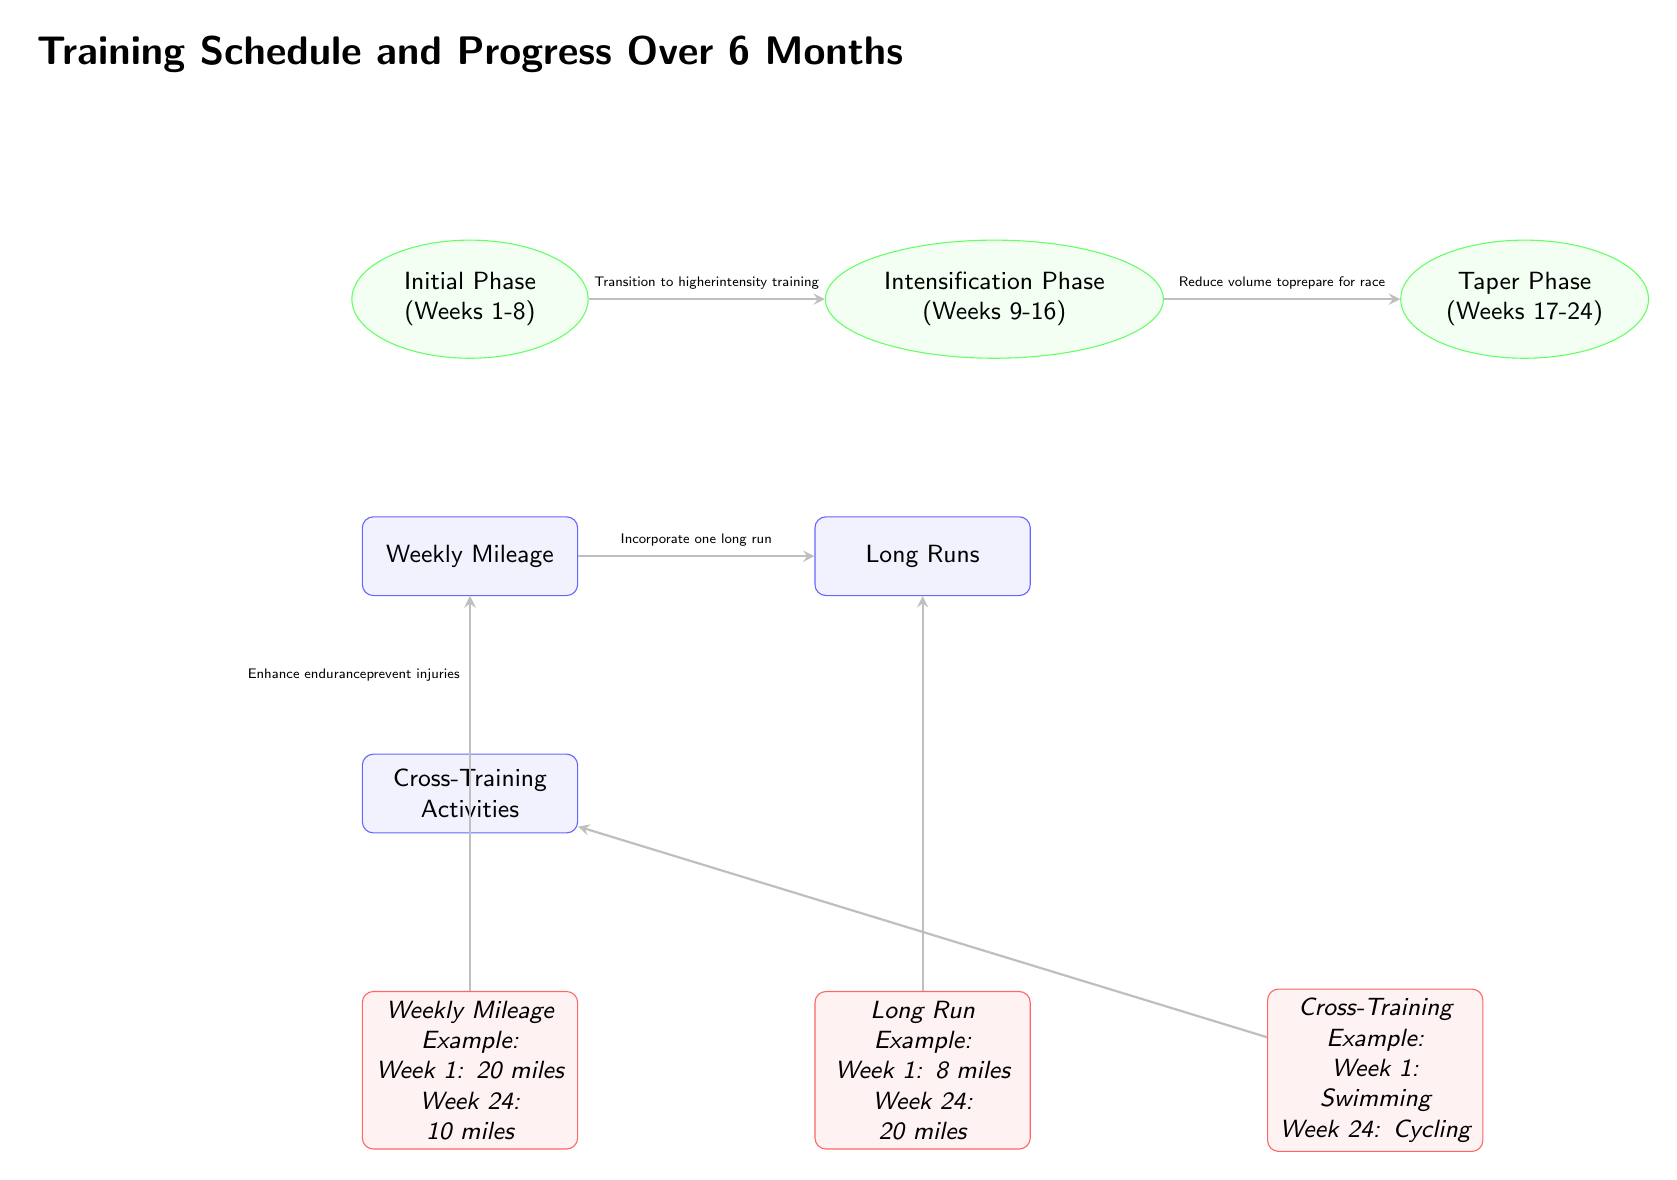What's the duration of the Initial Phase? The Initial Phase is labeled as "Weeks 1-8" in the diagram. Therefore, it lasts for 8 weeks.
Answer: 8 weeks What is the weekly mileage in Week 1? The diagram provides an example indicating the weekly mileage example for Week 1 is "20 miles."
Answer: 20 miles How many cross-training activities are mentioned in the diagram? The diagram has only one node related to Cross-Training Activities; therefore, it indicates one main category of activities.
Answer: 1 What is the long run distance in Week 24? According to the diagram, the long run example for Week 24 shows "20 miles."
Answer: 20 miles What is the purpose of incorporating one long run? The arrow leading from Weekly Mileage to Long Runs indicates that incorporating one long run is intended to increase endurance in training.
Answer: Increase endurance What phase comes after the Intensification Phase? The arrow leading from Intensification points to the Taper Phase, indicating that Taper is the next phase following Intensification.
Answer: Taper Phase What type of activities are suggested for Week 1 of Cross-Training? The example under Cross-Training Activities states "Swimming" for Week 1.
Answer: Swimming How does the diagram suggest you transition from the Initial Phase? The transition from the Initial Phase to the Intensification Phase is marked with the text "Transition to higher intensity training," indicating the change should aim for increased intensity.
Answer: Higher intensity training 